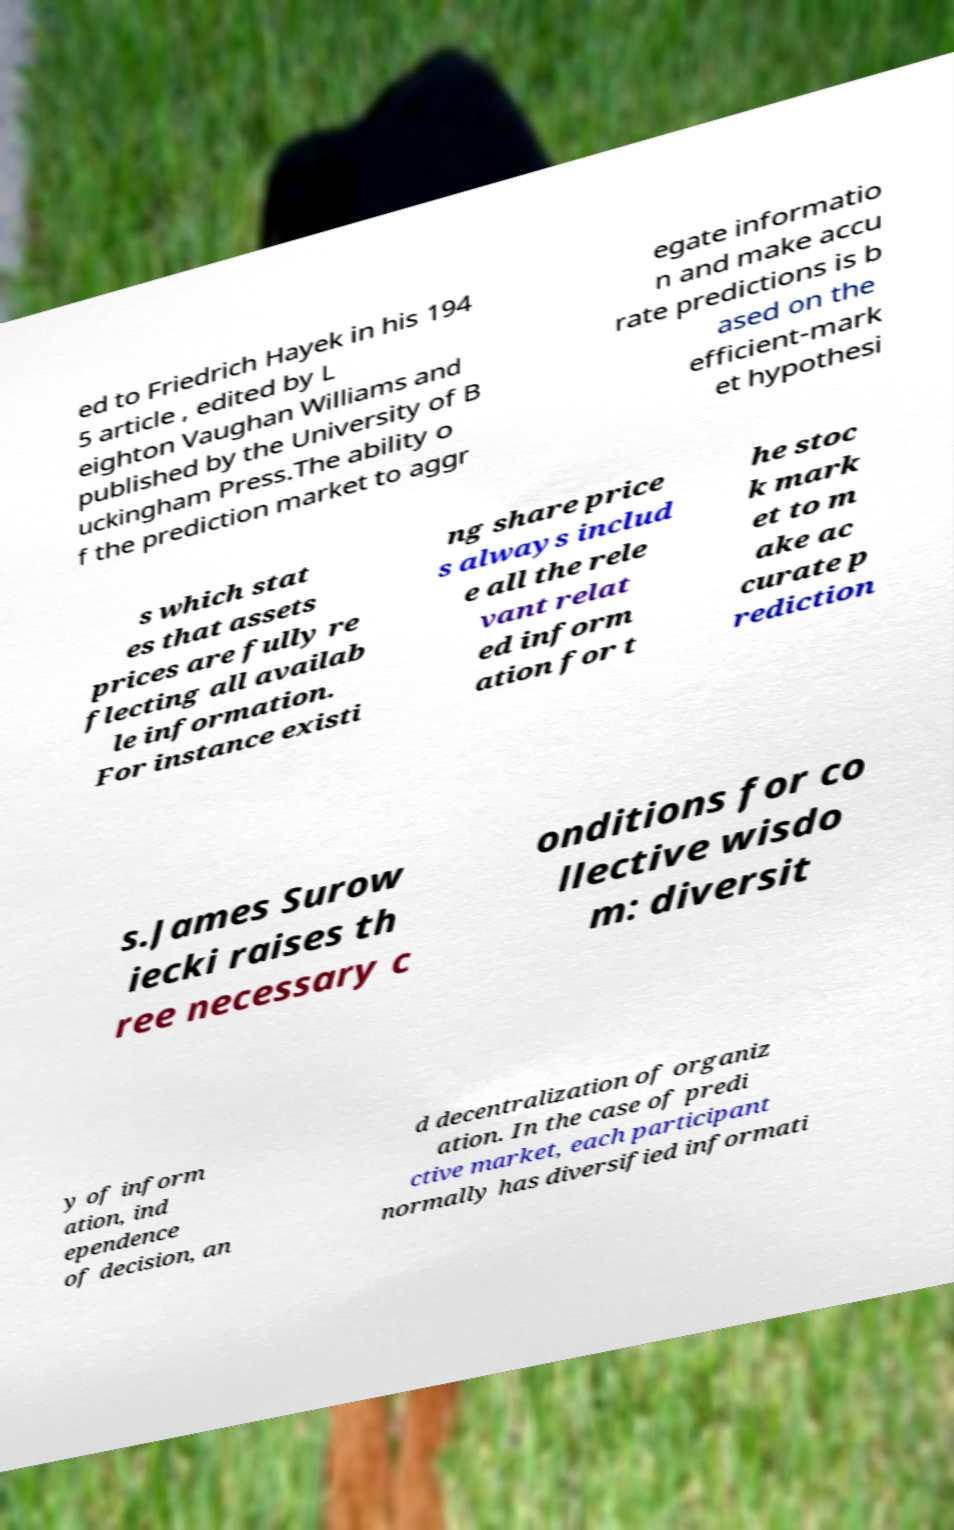Could you extract and type out the text from this image? ed to Friedrich Hayek in his 194 5 article , edited by L eighton Vaughan Williams and published by the University of B uckingham Press.The ability o f the prediction market to aggr egate informatio n and make accu rate predictions is b ased on the efficient-mark et hypothesi s which stat es that assets prices are fully re flecting all availab le information. For instance existi ng share price s always includ e all the rele vant relat ed inform ation for t he stoc k mark et to m ake ac curate p rediction s.James Surow iecki raises th ree necessary c onditions for co llective wisdo m: diversit y of inform ation, ind ependence of decision, an d decentralization of organiz ation. In the case of predi ctive market, each participant normally has diversified informati 